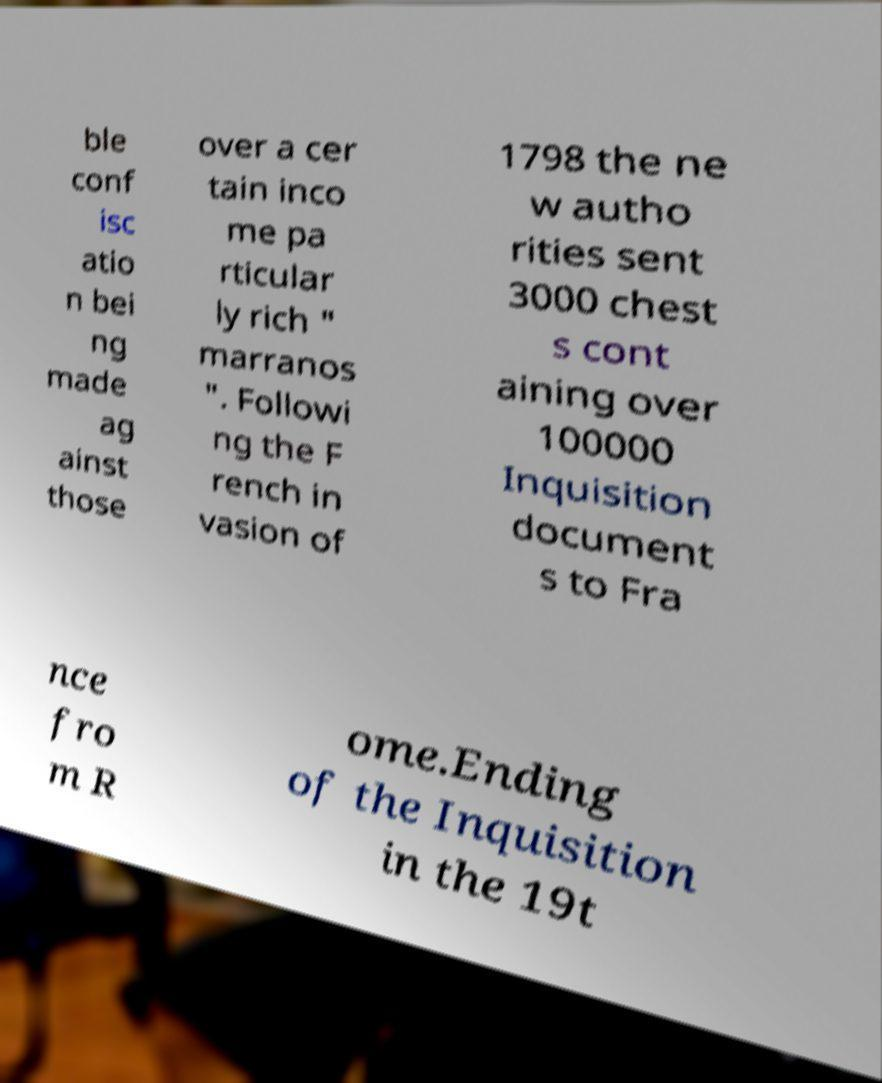Can you read and provide the text displayed in the image?This photo seems to have some interesting text. Can you extract and type it out for me? ble conf isc atio n bei ng made ag ainst those over a cer tain inco me pa rticular ly rich " marranos ". Followi ng the F rench in vasion of 1798 the ne w autho rities sent 3000 chest s cont aining over 100000 Inquisition document s to Fra nce fro m R ome.Ending of the Inquisition in the 19t 